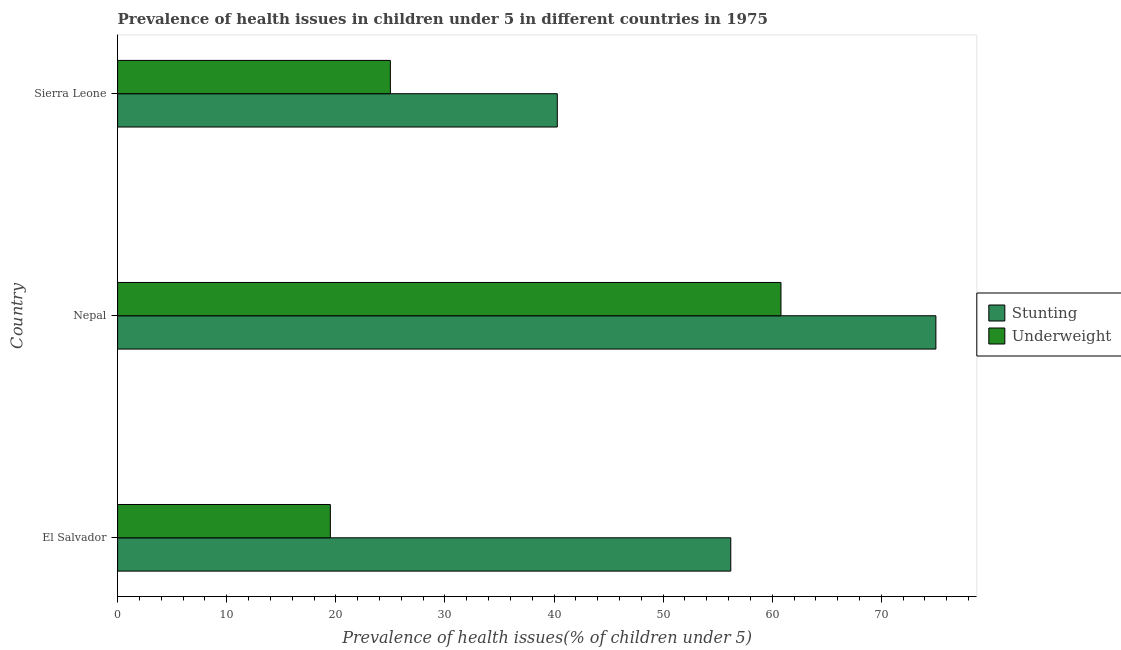How many different coloured bars are there?
Provide a succinct answer. 2. How many groups of bars are there?
Give a very brief answer. 3. Are the number of bars per tick equal to the number of legend labels?
Offer a terse response. Yes. How many bars are there on the 1st tick from the top?
Your answer should be very brief. 2. How many bars are there on the 1st tick from the bottom?
Keep it short and to the point. 2. What is the label of the 1st group of bars from the top?
Ensure brevity in your answer.  Sierra Leone. In how many cases, is the number of bars for a given country not equal to the number of legend labels?
Provide a succinct answer. 0. What is the percentage of stunted children in El Salvador?
Your answer should be very brief. 56.2. Across all countries, what is the maximum percentage of stunted children?
Give a very brief answer. 75. Across all countries, what is the minimum percentage of underweight children?
Provide a short and direct response. 19.5. In which country was the percentage of stunted children maximum?
Make the answer very short. Nepal. In which country was the percentage of stunted children minimum?
Ensure brevity in your answer.  Sierra Leone. What is the total percentage of stunted children in the graph?
Give a very brief answer. 171.5. What is the difference between the percentage of stunted children in Nepal and that in Sierra Leone?
Provide a succinct answer. 34.7. What is the difference between the percentage of underweight children in Sierra Leone and the percentage of stunted children in El Salvador?
Give a very brief answer. -31.2. What is the average percentage of stunted children per country?
Offer a very short reply. 57.17. What is the difference between the percentage of stunted children and percentage of underweight children in Nepal?
Ensure brevity in your answer.  14.2. In how many countries, is the percentage of stunted children greater than 48 %?
Your response must be concise. 2. What is the ratio of the percentage of stunted children in El Salvador to that in Nepal?
Your answer should be very brief. 0.75. Is the percentage of stunted children in El Salvador less than that in Sierra Leone?
Your answer should be compact. No. What is the difference between the highest and the second highest percentage of underweight children?
Your response must be concise. 35.8. What is the difference between the highest and the lowest percentage of stunted children?
Offer a terse response. 34.7. Is the sum of the percentage of stunted children in El Salvador and Sierra Leone greater than the maximum percentage of underweight children across all countries?
Offer a terse response. Yes. What does the 2nd bar from the top in Nepal represents?
Make the answer very short. Stunting. What does the 1st bar from the bottom in El Salvador represents?
Provide a short and direct response. Stunting. What is the difference between two consecutive major ticks on the X-axis?
Your answer should be very brief. 10. Are the values on the major ticks of X-axis written in scientific E-notation?
Keep it short and to the point. No. Does the graph contain any zero values?
Provide a succinct answer. No. Does the graph contain grids?
Ensure brevity in your answer.  No. Where does the legend appear in the graph?
Your answer should be compact. Center right. How many legend labels are there?
Your response must be concise. 2. How are the legend labels stacked?
Keep it short and to the point. Vertical. What is the title of the graph?
Offer a very short reply. Prevalence of health issues in children under 5 in different countries in 1975. What is the label or title of the X-axis?
Offer a terse response. Prevalence of health issues(% of children under 5). What is the label or title of the Y-axis?
Your response must be concise. Country. What is the Prevalence of health issues(% of children under 5) in Stunting in El Salvador?
Your answer should be compact. 56.2. What is the Prevalence of health issues(% of children under 5) of Underweight in El Salvador?
Offer a terse response. 19.5. What is the Prevalence of health issues(% of children under 5) in Underweight in Nepal?
Your answer should be very brief. 60.8. What is the Prevalence of health issues(% of children under 5) of Stunting in Sierra Leone?
Keep it short and to the point. 40.3. Across all countries, what is the maximum Prevalence of health issues(% of children under 5) in Underweight?
Give a very brief answer. 60.8. Across all countries, what is the minimum Prevalence of health issues(% of children under 5) in Stunting?
Give a very brief answer. 40.3. What is the total Prevalence of health issues(% of children under 5) of Stunting in the graph?
Your answer should be very brief. 171.5. What is the total Prevalence of health issues(% of children under 5) in Underweight in the graph?
Your answer should be compact. 105.3. What is the difference between the Prevalence of health issues(% of children under 5) in Stunting in El Salvador and that in Nepal?
Make the answer very short. -18.8. What is the difference between the Prevalence of health issues(% of children under 5) in Underweight in El Salvador and that in Nepal?
Your answer should be compact. -41.3. What is the difference between the Prevalence of health issues(% of children under 5) of Underweight in El Salvador and that in Sierra Leone?
Make the answer very short. -5.5. What is the difference between the Prevalence of health issues(% of children under 5) in Stunting in Nepal and that in Sierra Leone?
Your response must be concise. 34.7. What is the difference between the Prevalence of health issues(% of children under 5) in Underweight in Nepal and that in Sierra Leone?
Keep it short and to the point. 35.8. What is the difference between the Prevalence of health issues(% of children under 5) in Stunting in El Salvador and the Prevalence of health issues(% of children under 5) in Underweight in Nepal?
Keep it short and to the point. -4.6. What is the difference between the Prevalence of health issues(% of children under 5) in Stunting in El Salvador and the Prevalence of health issues(% of children under 5) in Underweight in Sierra Leone?
Ensure brevity in your answer.  31.2. What is the average Prevalence of health issues(% of children under 5) in Stunting per country?
Your response must be concise. 57.17. What is the average Prevalence of health issues(% of children under 5) in Underweight per country?
Provide a short and direct response. 35.1. What is the difference between the Prevalence of health issues(% of children under 5) in Stunting and Prevalence of health issues(% of children under 5) in Underweight in El Salvador?
Provide a short and direct response. 36.7. What is the difference between the Prevalence of health issues(% of children under 5) of Stunting and Prevalence of health issues(% of children under 5) of Underweight in Sierra Leone?
Your response must be concise. 15.3. What is the ratio of the Prevalence of health issues(% of children under 5) of Stunting in El Salvador to that in Nepal?
Provide a succinct answer. 0.75. What is the ratio of the Prevalence of health issues(% of children under 5) in Underweight in El Salvador to that in Nepal?
Offer a terse response. 0.32. What is the ratio of the Prevalence of health issues(% of children under 5) of Stunting in El Salvador to that in Sierra Leone?
Your answer should be very brief. 1.39. What is the ratio of the Prevalence of health issues(% of children under 5) of Underweight in El Salvador to that in Sierra Leone?
Your response must be concise. 0.78. What is the ratio of the Prevalence of health issues(% of children under 5) of Stunting in Nepal to that in Sierra Leone?
Your answer should be compact. 1.86. What is the ratio of the Prevalence of health issues(% of children under 5) of Underweight in Nepal to that in Sierra Leone?
Provide a succinct answer. 2.43. What is the difference between the highest and the second highest Prevalence of health issues(% of children under 5) in Stunting?
Provide a short and direct response. 18.8. What is the difference between the highest and the second highest Prevalence of health issues(% of children under 5) of Underweight?
Keep it short and to the point. 35.8. What is the difference between the highest and the lowest Prevalence of health issues(% of children under 5) of Stunting?
Provide a succinct answer. 34.7. What is the difference between the highest and the lowest Prevalence of health issues(% of children under 5) in Underweight?
Your answer should be compact. 41.3. 